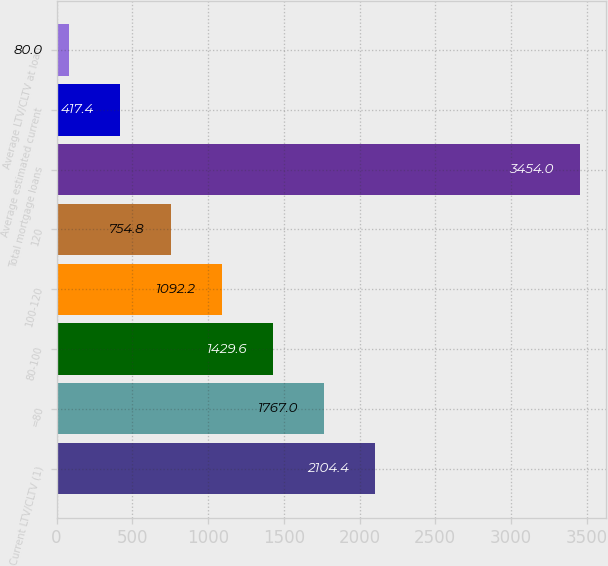<chart> <loc_0><loc_0><loc_500><loc_500><bar_chart><fcel>Current LTV/CLTV (1)<fcel>=80<fcel>80-100<fcel>100-120<fcel>120<fcel>Total mortgage loans<fcel>Average estimated current<fcel>Average LTV/CLTV at loan<nl><fcel>2104.4<fcel>1767<fcel>1429.6<fcel>1092.2<fcel>754.8<fcel>3454<fcel>417.4<fcel>80<nl></chart> 